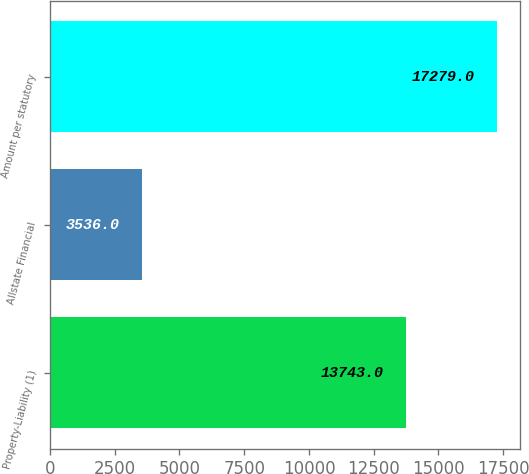<chart> <loc_0><loc_0><loc_500><loc_500><bar_chart><fcel>Property-Liability (1)<fcel>Allstate Financial<fcel>Amount per statutory<nl><fcel>13743<fcel>3536<fcel>17279<nl></chart> 